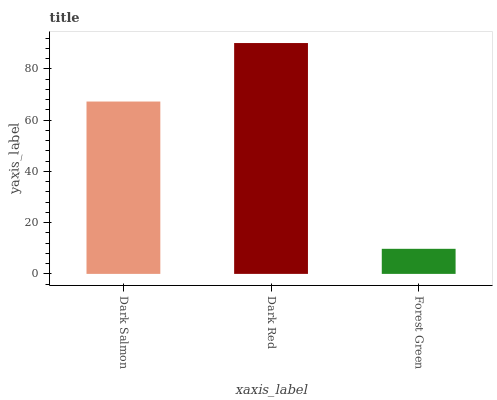Is Forest Green the minimum?
Answer yes or no. Yes. Is Dark Red the maximum?
Answer yes or no. Yes. Is Dark Red the minimum?
Answer yes or no. No. Is Forest Green the maximum?
Answer yes or no. No. Is Dark Red greater than Forest Green?
Answer yes or no. Yes. Is Forest Green less than Dark Red?
Answer yes or no. Yes. Is Forest Green greater than Dark Red?
Answer yes or no. No. Is Dark Red less than Forest Green?
Answer yes or no. No. Is Dark Salmon the high median?
Answer yes or no. Yes. Is Dark Salmon the low median?
Answer yes or no. Yes. Is Dark Red the high median?
Answer yes or no. No. Is Forest Green the low median?
Answer yes or no. No. 